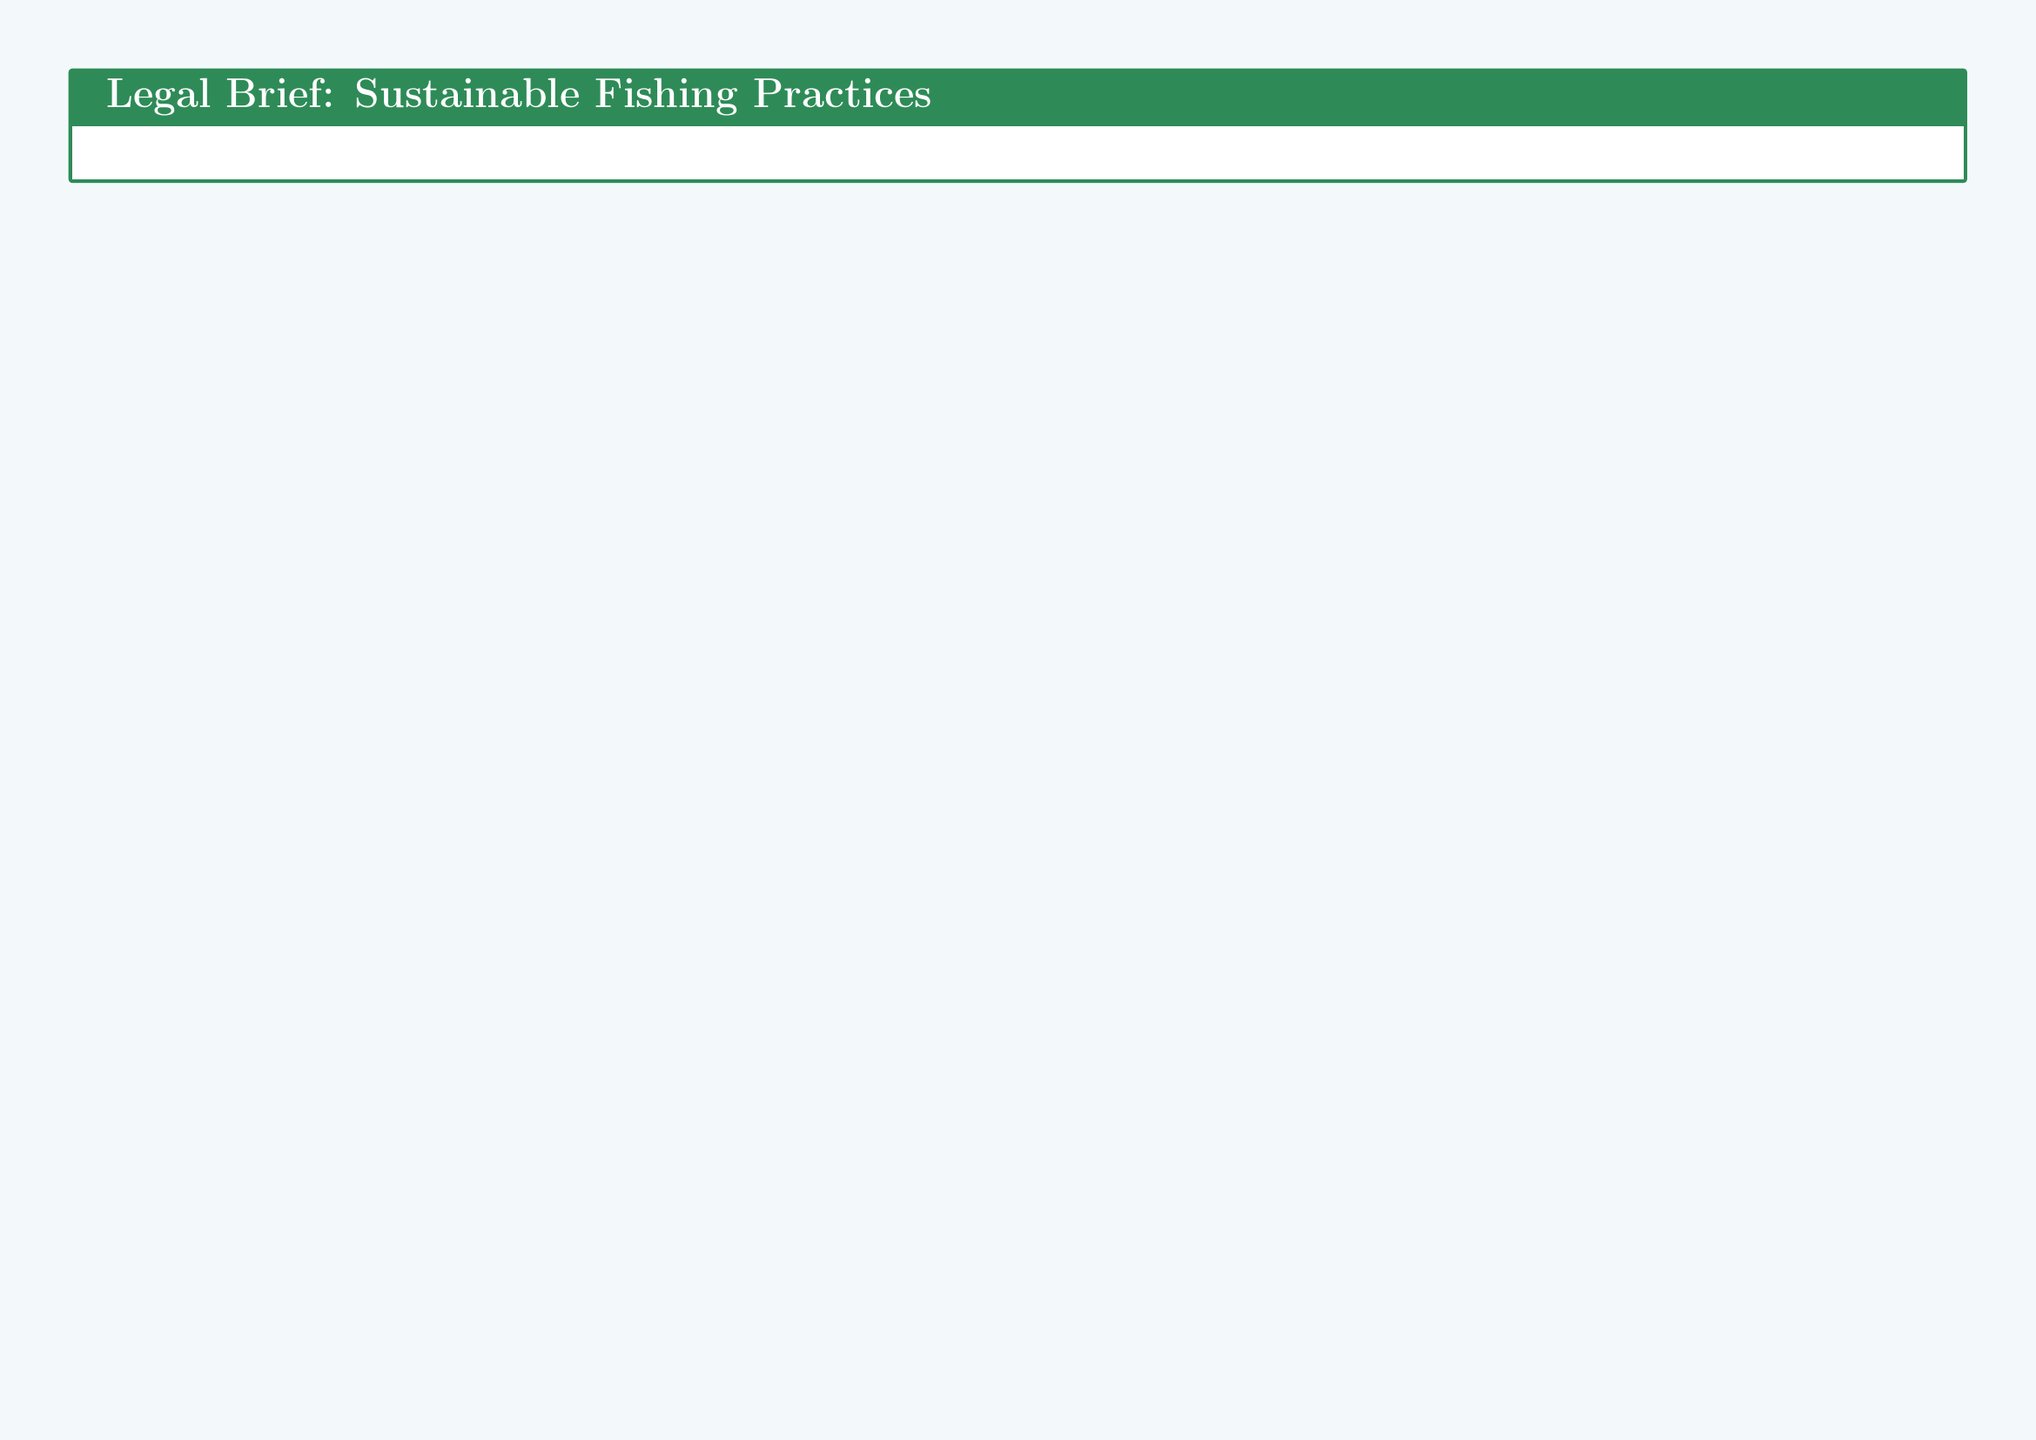What is the key legislation for sustainable fishing? The document identifies the Magnuson-Stevens Fishery Conservation and Management Act as the key legislation pertaining to sustainable fishing practices.
Answer: Magnuson-Stevens Fishery Conservation and Management Act What are some compliance measures mentioned for sustainable fishing? The document lists fishing quotas, permits, and electronic monitoring as compliance measures for sustainable fishing initiatives.
Answer: Fishing quotas, permits, electronic monitoring What is the maximum penalty for violations? The legal brief mentions fines up to hundreds of thousands and possible imprisonment as penalties for violations of sustainable fishing regulations.
Answer: Hundreds of thousands, possible imprisonment Which agreement focuses on international trade and sustainable fishing? The legal brief describes the UN Fish Stocks Agreement as a key international trade agreement impacting sustainable fisheries.
Answer: UN Fish Stocks Agreement What is a suggested improvement for IUU fishing enforcement? The document proposes enhanced satellite monitoring as one of the improvements for the enforcement of policies against illegal, unreported, and unregulated fishing.
Answer: Enhanced satellite monitoring What type of funding is available for sustainable fishing transitions? The document indicates that low-interest loans are available for organizations and fishermen transitioning to sustainable fishing practices.
Answer: Low-interest loans What is the eligibility criterion for funding? To be eligible for funding, organizations must demonstrate sustainability commitments as stated in the legal brief.
Answer: Demonstrate sustainability commitments Which legal framework aims to protect marine biodiversity? The document cites the Convention on Biological Diversity (CBD) as a legal framework aimed at protecting marine ecosystems and biodiversity.
Answer: Convention on Biological Diversity What is one of the minister's key priorities? The document outlines strengthening compliance with sustainable fishing regulations as one of the key priorities of the fisheries minister.
Answer: Strengthen compliance with sustainable fishing regulations 